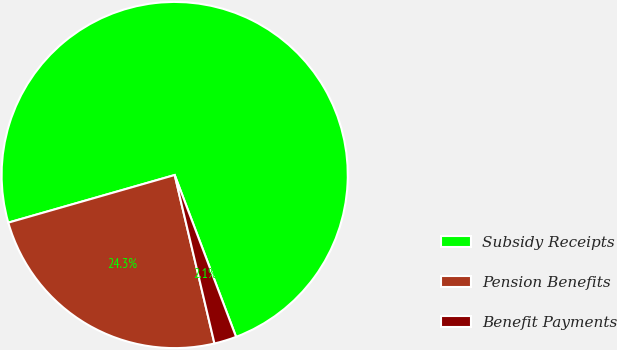Convert chart. <chart><loc_0><loc_0><loc_500><loc_500><pie_chart><fcel>Subsidy Receipts<fcel>Pension Benefits<fcel>Benefit Payments<nl><fcel>73.66%<fcel>24.25%<fcel>2.08%<nl></chart> 